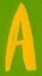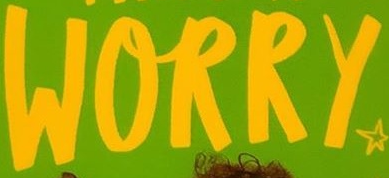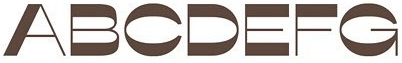What text appears in these images from left to right, separated by a semicolon? A; WORRY; ABCDEFG 